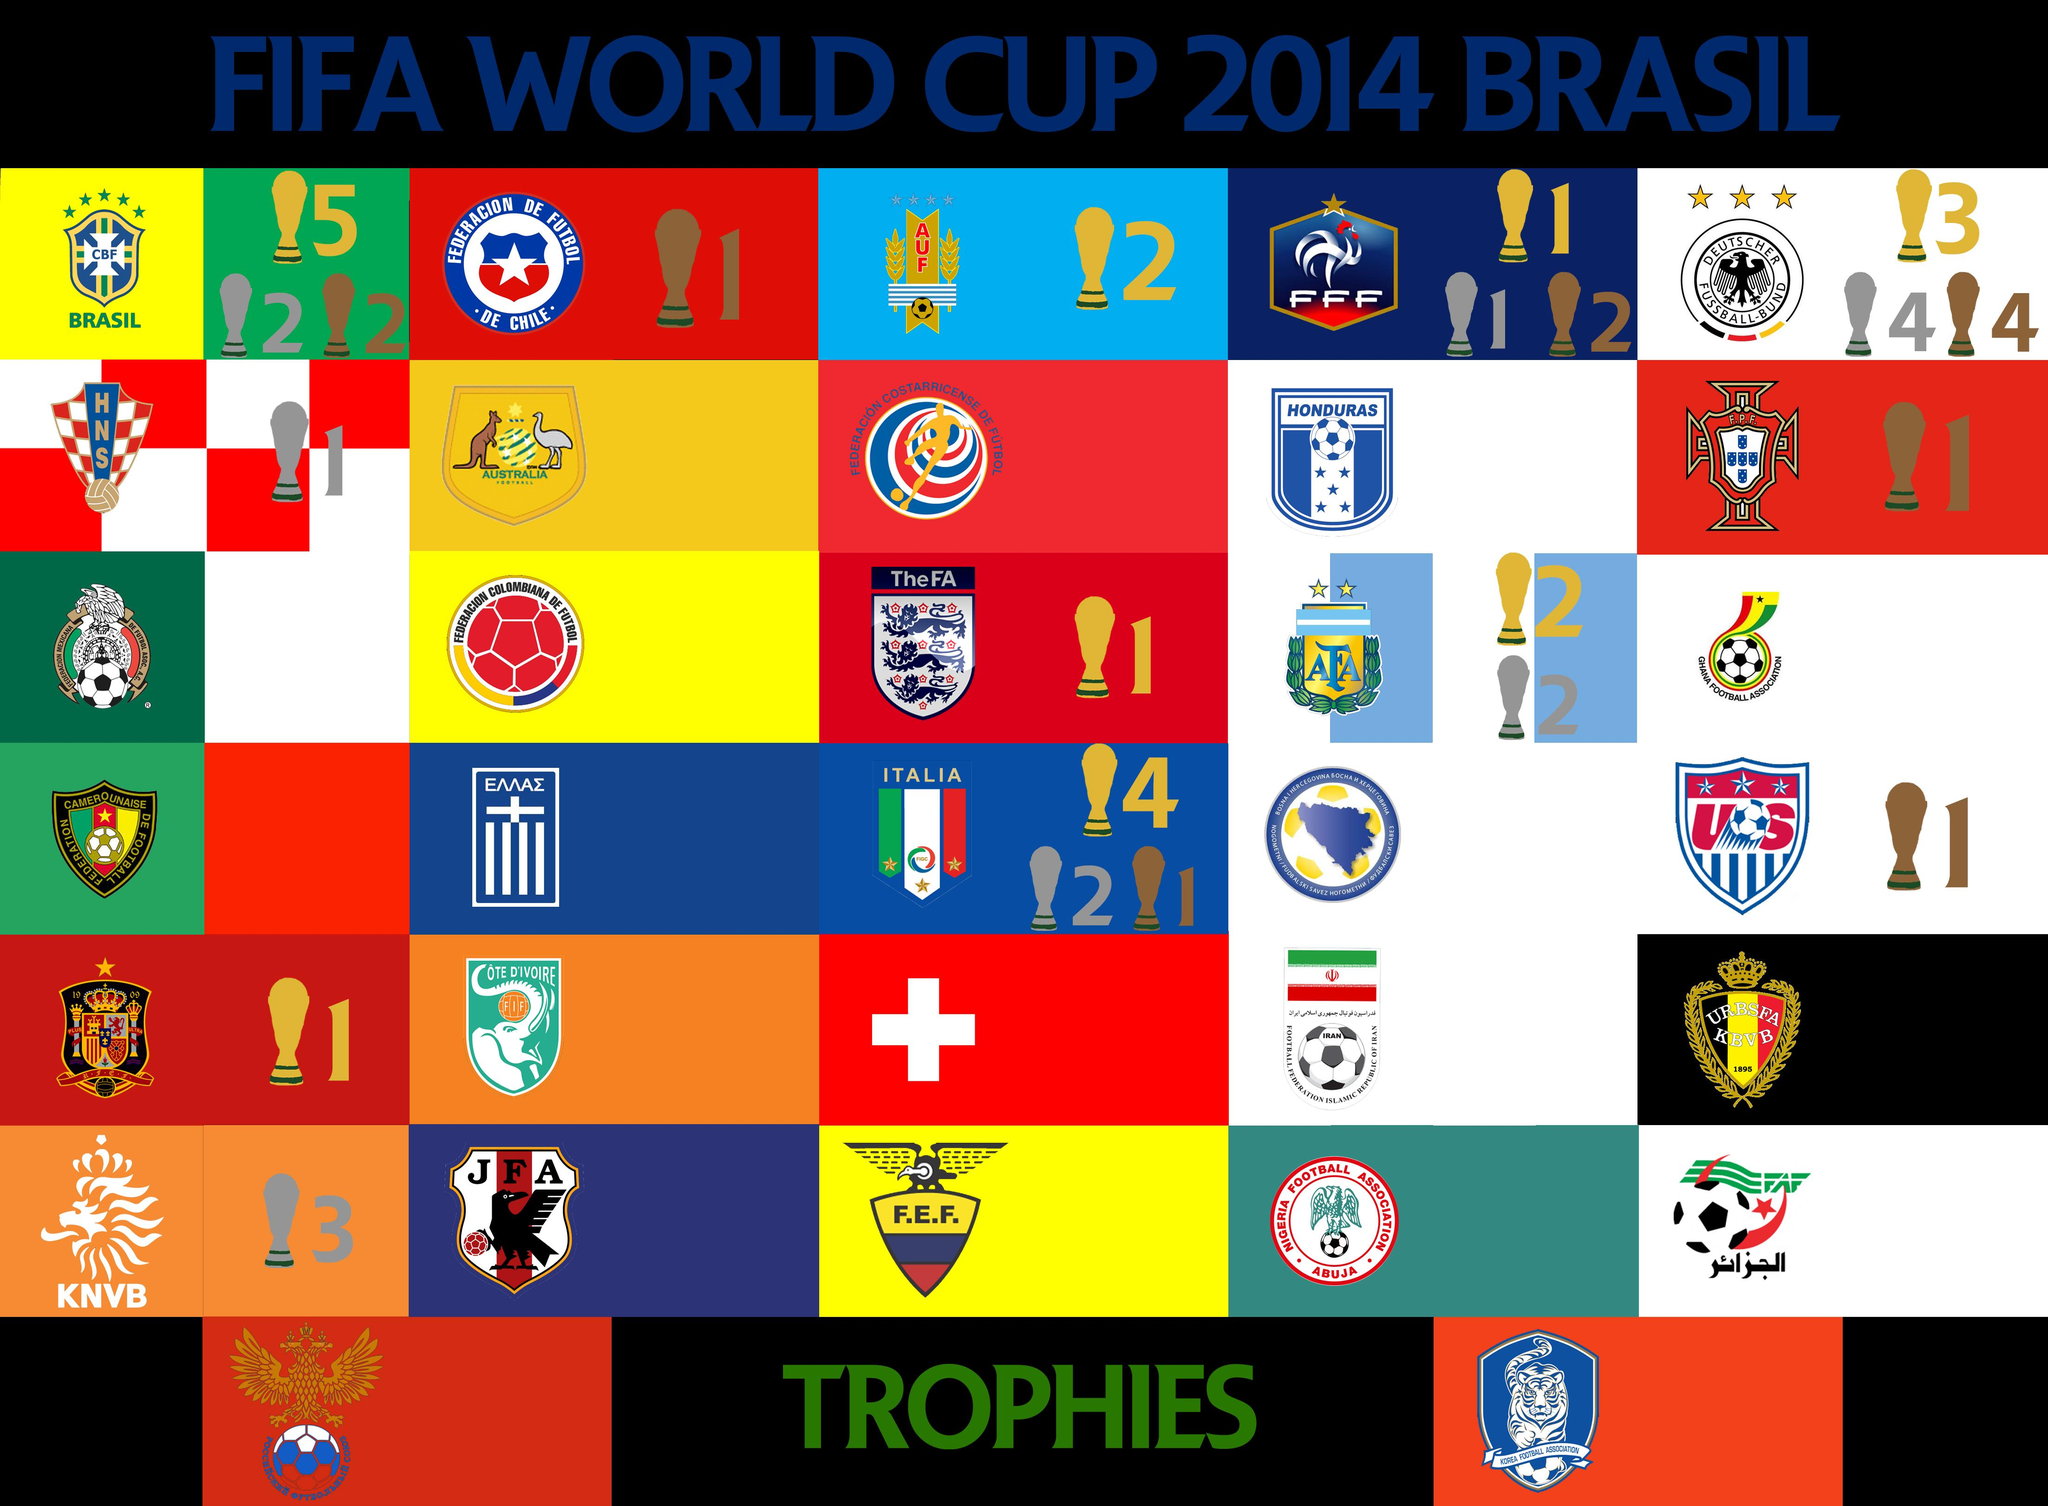List a handful of essential elements in this visual. The country represented by a Kangaroo and an Ostrich in their football association is Australia. The Korean Football Association is known for its distinct image of a tiger, setting it apart from other football associations. 